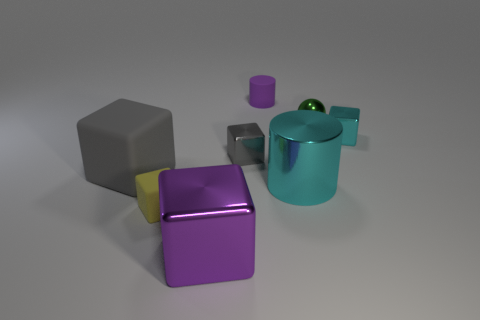Is the color of the large shiny cube the same as the matte cylinder?
Provide a succinct answer. Yes. The large gray object has what shape?
Give a very brief answer. Cube. How many objects are small metal spheres or large cylinders?
Make the answer very short. 2. Are there any purple matte things?
Your answer should be compact. Yes. Are there fewer metallic cylinders than brown metal objects?
Your answer should be compact. No. Is there a cyan cylinder that has the same size as the purple metallic block?
Provide a short and direct response. Yes. Does the gray metallic object have the same shape as the thing that is behind the small metal ball?
Ensure brevity in your answer.  No. What number of cylinders are either small green objects or yellow matte objects?
Provide a short and direct response. 0. The tiny cylinder is what color?
Your answer should be compact. Purple. Are there more yellow things than big matte balls?
Provide a short and direct response. Yes. 